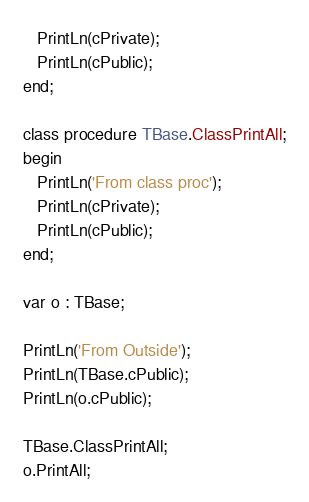<code> <loc_0><loc_0><loc_500><loc_500><_Pascal_>   PrintLn(cPrivate);
   PrintLn(cPublic);
end;

class procedure TBase.ClassPrintAll;
begin
   PrintLn('From class proc');
   PrintLn(cPrivate);
   PrintLn(cPublic);
end;

var o : TBase;

PrintLn('From Outside');
PrintLn(TBase.cPublic);
PrintLn(o.cPublic);

TBase.ClassPrintAll;
o.PrintAll;






</code> 